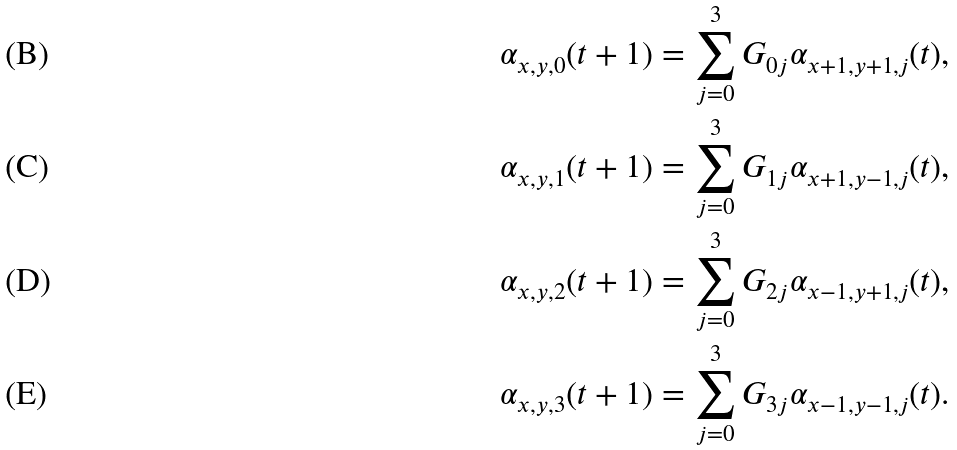<formula> <loc_0><loc_0><loc_500><loc_500>\alpha _ { x , y , 0 } ( t + 1 ) & = \sum _ { j = 0 } ^ { 3 } G _ { 0 j } \alpha _ { x + 1 , y + 1 , j } ( t ) , \\ \alpha _ { x , y , 1 } ( t + 1 ) & = \sum _ { j = 0 } ^ { 3 } G _ { 1 j } \alpha _ { x + 1 , y - 1 , j } ( t ) , \\ \alpha _ { x , y , 2 } ( t + 1 ) & = \sum _ { j = 0 } ^ { 3 } G _ { 2 j } \alpha _ { x - 1 , y + 1 , j } ( t ) , \\ \alpha _ { x , y , 3 } ( t + 1 ) & = \sum _ { j = 0 } ^ { 3 } G _ { 3 j } \alpha _ { x - 1 , y - 1 , j } ( t ) .</formula> 